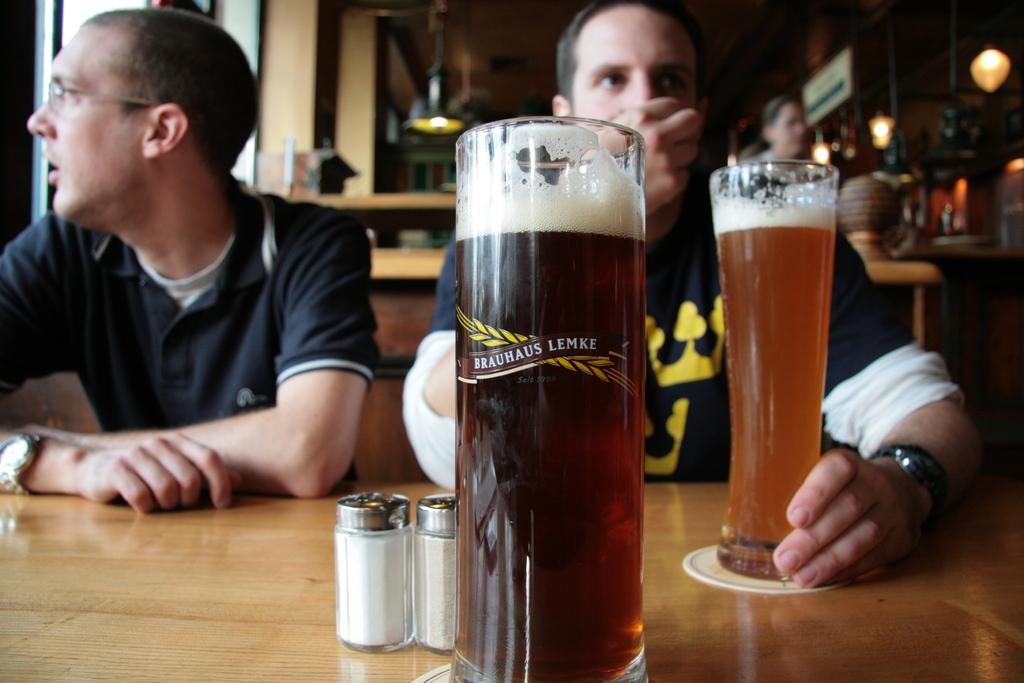What is on the table in the image? There are glasses of beer on the table. Who is present in the image? There are two men sitting in front of the table. How many sheep can be seen in the image? There are no sheep present in the image. What type of camera is being used to take the picture? The image does not show any camera being used to take the picture. 